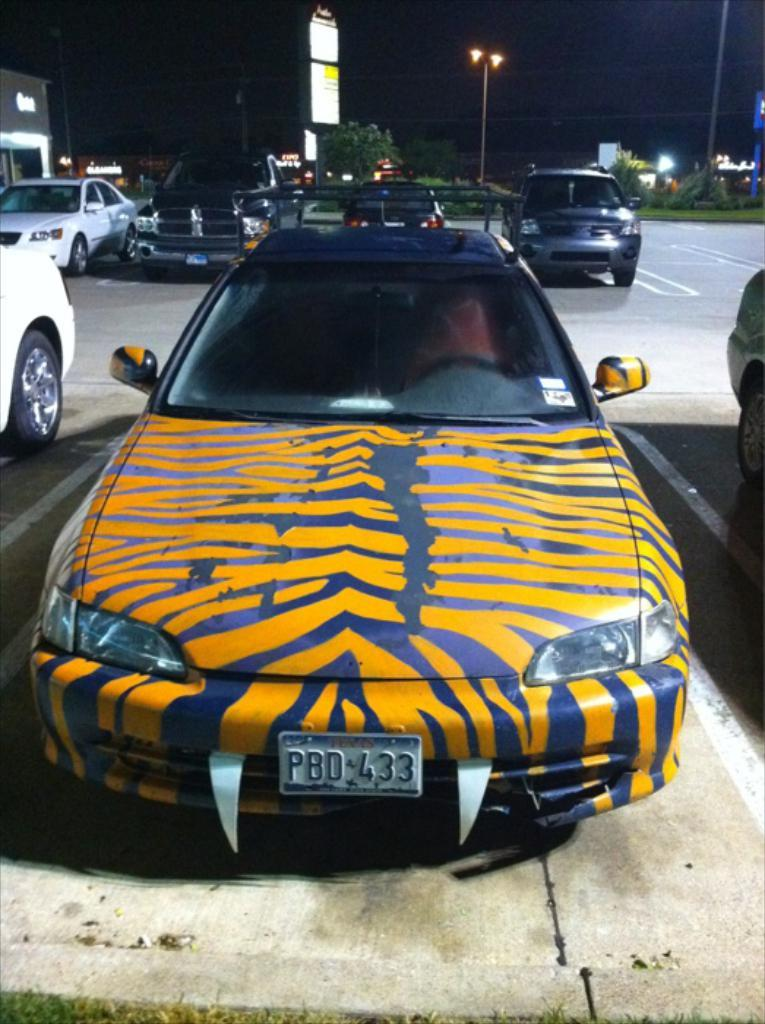<image>
Present a compact description of the photo's key features. The registration of this funky tiger print painted car, is PBD433. 